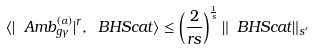Convert formula to latex. <formula><loc_0><loc_0><loc_500><loc_500>\langle | \ A m b ^ { ( \alpha ) } _ { g \gamma } | ^ { r } , \ B H S c a t \rangle \leq \left ( \frac { 2 } { r s } \right ) ^ { \frac { 1 } { s } } \| \ B H S c a t \| _ { s ^ { \prime } }</formula> 